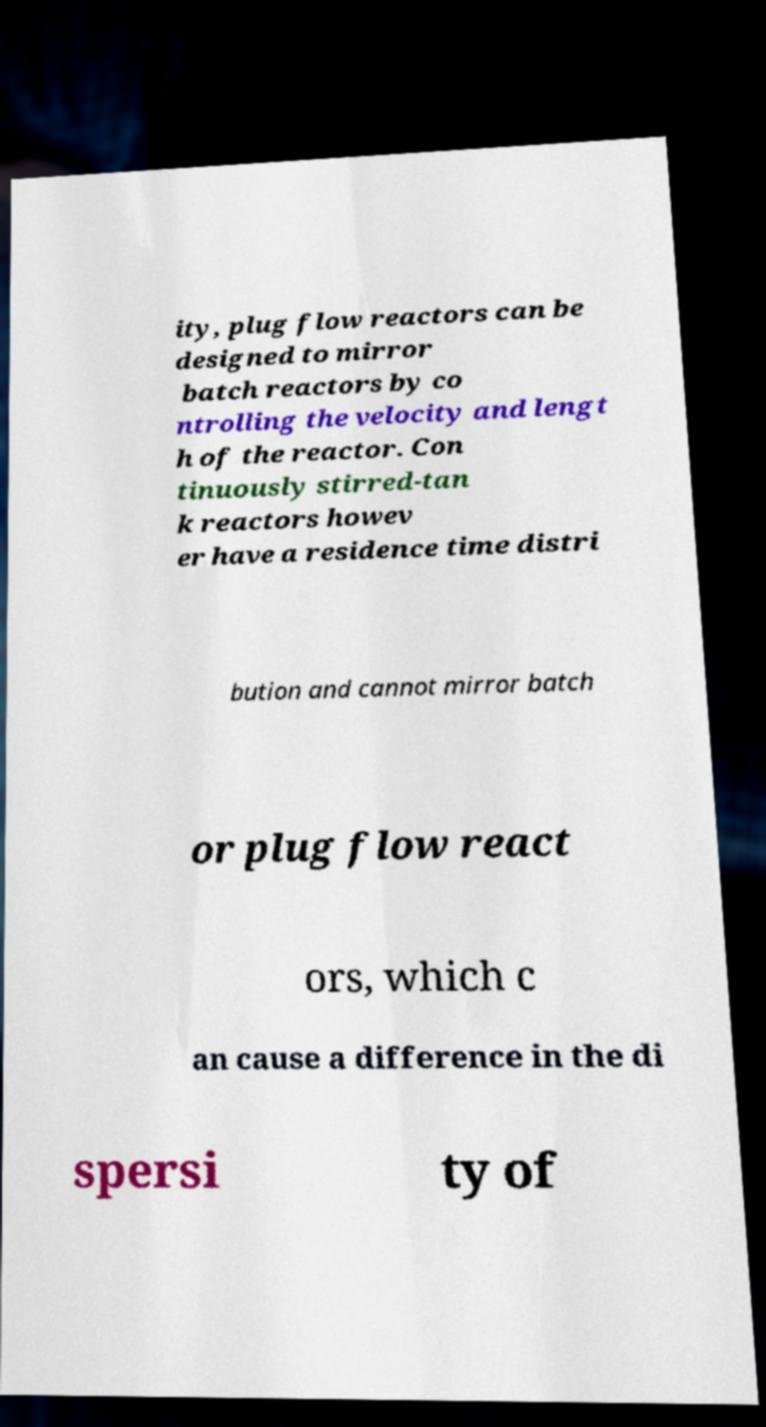Please read and relay the text visible in this image. What does it say? ity, plug flow reactors can be designed to mirror batch reactors by co ntrolling the velocity and lengt h of the reactor. Con tinuously stirred-tan k reactors howev er have a residence time distri bution and cannot mirror batch or plug flow react ors, which c an cause a difference in the di spersi ty of 